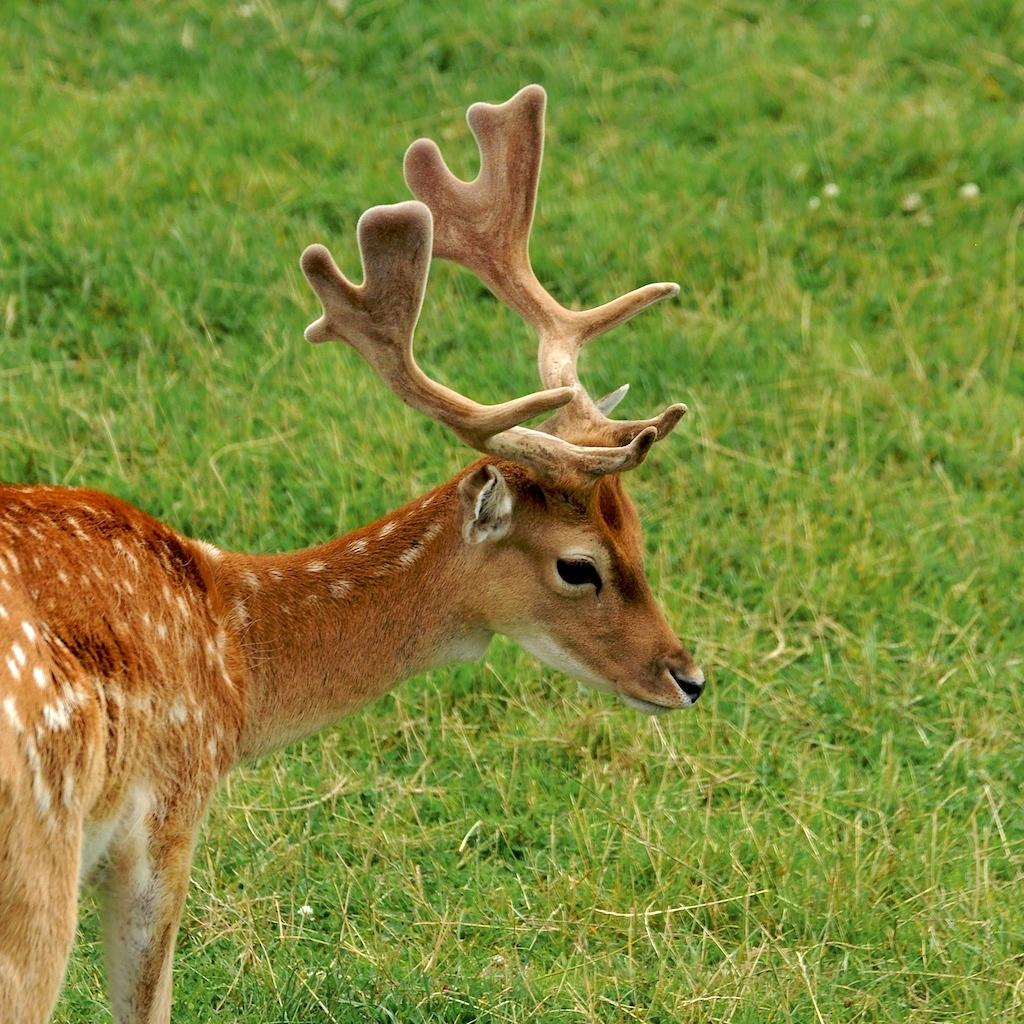What animal is present in the image? There is a deer in the image. What type of surface is the deer standing on? The deer is on a grass surface. What type of steel is used to make the birthday cake in the image? There is no birthday cake or steel present in the image; it features a deer on a grass surface. 